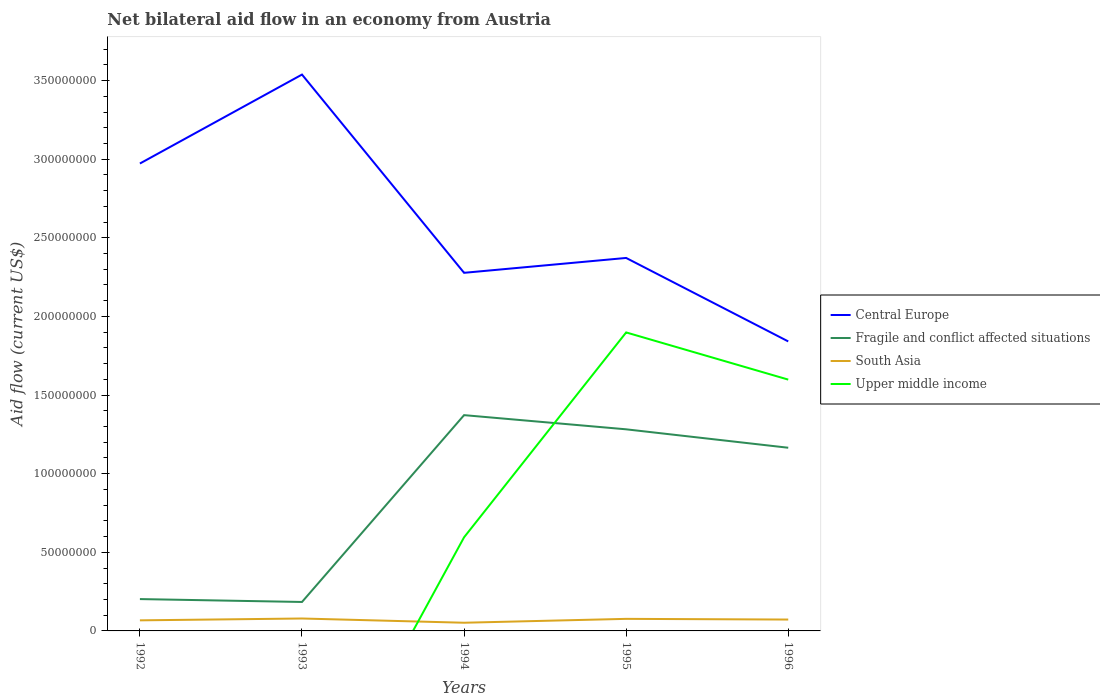How many different coloured lines are there?
Offer a terse response. 4. Is the number of lines equal to the number of legend labels?
Ensure brevity in your answer.  No. Across all years, what is the maximum net bilateral aid flow in Upper middle income?
Your response must be concise. 0. What is the total net bilateral aid flow in Upper middle income in the graph?
Offer a terse response. -1.30e+08. What is the difference between the highest and the second highest net bilateral aid flow in Central Europe?
Offer a terse response. 1.70e+08. How many lines are there?
Your response must be concise. 4. Are the values on the major ticks of Y-axis written in scientific E-notation?
Give a very brief answer. No. Does the graph contain grids?
Offer a very short reply. No. Where does the legend appear in the graph?
Your answer should be compact. Center right. How many legend labels are there?
Make the answer very short. 4. How are the legend labels stacked?
Provide a short and direct response. Vertical. What is the title of the graph?
Offer a terse response. Net bilateral aid flow in an economy from Austria. What is the Aid flow (current US$) in Central Europe in 1992?
Make the answer very short. 2.97e+08. What is the Aid flow (current US$) of Fragile and conflict affected situations in 1992?
Provide a short and direct response. 2.02e+07. What is the Aid flow (current US$) in South Asia in 1992?
Your answer should be very brief. 6.73e+06. What is the Aid flow (current US$) in Central Europe in 1993?
Your answer should be very brief. 3.54e+08. What is the Aid flow (current US$) in Fragile and conflict affected situations in 1993?
Offer a very short reply. 1.84e+07. What is the Aid flow (current US$) in South Asia in 1993?
Offer a very short reply. 7.90e+06. What is the Aid flow (current US$) of Central Europe in 1994?
Give a very brief answer. 2.28e+08. What is the Aid flow (current US$) in Fragile and conflict affected situations in 1994?
Keep it short and to the point. 1.37e+08. What is the Aid flow (current US$) of South Asia in 1994?
Your answer should be compact. 5.21e+06. What is the Aid flow (current US$) of Upper middle income in 1994?
Provide a succinct answer. 5.96e+07. What is the Aid flow (current US$) in Central Europe in 1995?
Your response must be concise. 2.37e+08. What is the Aid flow (current US$) of Fragile and conflict affected situations in 1995?
Give a very brief answer. 1.28e+08. What is the Aid flow (current US$) of South Asia in 1995?
Keep it short and to the point. 7.67e+06. What is the Aid flow (current US$) of Upper middle income in 1995?
Your answer should be compact. 1.90e+08. What is the Aid flow (current US$) in Central Europe in 1996?
Ensure brevity in your answer.  1.84e+08. What is the Aid flow (current US$) of Fragile and conflict affected situations in 1996?
Make the answer very short. 1.16e+08. What is the Aid flow (current US$) in South Asia in 1996?
Make the answer very short. 7.23e+06. What is the Aid flow (current US$) in Upper middle income in 1996?
Keep it short and to the point. 1.60e+08. Across all years, what is the maximum Aid flow (current US$) of Central Europe?
Your response must be concise. 3.54e+08. Across all years, what is the maximum Aid flow (current US$) of Fragile and conflict affected situations?
Provide a succinct answer. 1.37e+08. Across all years, what is the maximum Aid flow (current US$) in South Asia?
Your response must be concise. 7.90e+06. Across all years, what is the maximum Aid flow (current US$) in Upper middle income?
Ensure brevity in your answer.  1.90e+08. Across all years, what is the minimum Aid flow (current US$) of Central Europe?
Make the answer very short. 1.84e+08. Across all years, what is the minimum Aid flow (current US$) of Fragile and conflict affected situations?
Offer a very short reply. 1.84e+07. Across all years, what is the minimum Aid flow (current US$) of South Asia?
Provide a succinct answer. 5.21e+06. Across all years, what is the minimum Aid flow (current US$) of Upper middle income?
Make the answer very short. 0. What is the total Aid flow (current US$) of Central Europe in the graph?
Your response must be concise. 1.30e+09. What is the total Aid flow (current US$) of Fragile and conflict affected situations in the graph?
Your answer should be compact. 4.21e+08. What is the total Aid flow (current US$) of South Asia in the graph?
Offer a very short reply. 3.47e+07. What is the total Aid flow (current US$) of Upper middle income in the graph?
Make the answer very short. 4.09e+08. What is the difference between the Aid flow (current US$) in Central Europe in 1992 and that in 1993?
Ensure brevity in your answer.  -5.66e+07. What is the difference between the Aid flow (current US$) in Fragile and conflict affected situations in 1992 and that in 1993?
Your response must be concise. 1.84e+06. What is the difference between the Aid flow (current US$) in South Asia in 1992 and that in 1993?
Your answer should be compact. -1.17e+06. What is the difference between the Aid flow (current US$) in Central Europe in 1992 and that in 1994?
Your answer should be very brief. 6.95e+07. What is the difference between the Aid flow (current US$) in Fragile and conflict affected situations in 1992 and that in 1994?
Make the answer very short. -1.17e+08. What is the difference between the Aid flow (current US$) in South Asia in 1992 and that in 1994?
Offer a terse response. 1.52e+06. What is the difference between the Aid flow (current US$) of Central Europe in 1992 and that in 1995?
Offer a very short reply. 6.00e+07. What is the difference between the Aid flow (current US$) of Fragile and conflict affected situations in 1992 and that in 1995?
Your answer should be very brief. -1.08e+08. What is the difference between the Aid flow (current US$) in South Asia in 1992 and that in 1995?
Provide a succinct answer. -9.40e+05. What is the difference between the Aid flow (current US$) of Central Europe in 1992 and that in 1996?
Offer a terse response. 1.13e+08. What is the difference between the Aid flow (current US$) of Fragile and conflict affected situations in 1992 and that in 1996?
Keep it short and to the point. -9.62e+07. What is the difference between the Aid flow (current US$) in South Asia in 1992 and that in 1996?
Make the answer very short. -5.00e+05. What is the difference between the Aid flow (current US$) of Central Europe in 1993 and that in 1994?
Your answer should be very brief. 1.26e+08. What is the difference between the Aid flow (current US$) of Fragile and conflict affected situations in 1993 and that in 1994?
Provide a short and direct response. -1.19e+08. What is the difference between the Aid flow (current US$) of South Asia in 1993 and that in 1994?
Provide a short and direct response. 2.69e+06. What is the difference between the Aid flow (current US$) of Central Europe in 1993 and that in 1995?
Provide a short and direct response. 1.17e+08. What is the difference between the Aid flow (current US$) of Fragile and conflict affected situations in 1993 and that in 1995?
Your answer should be very brief. -1.10e+08. What is the difference between the Aid flow (current US$) of South Asia in 1993 and that in 1995?
Your answer should be very brief. 2.30e+05. What is the difference between the Aid flow (current US$) in Central Europe in 1993 and that in 1996?
Make the answer very short. 1.70e+08. What is the difference between the Aid flow (current US$) in Fragile and conflict affected situations in 1993 and that in 1996?
Provide a short and direct response. -9.81e+07. What is the difference between the Aid flow (current US$) in South Asia in 1993 and that in 1996?
Make the answer very short. 6.70e+05. What is the difference between the Aid flow (current US$) of Central Europe in 1994 and that in 1995?
Your response must be concise. -9.45e+06. What is the difference between the Aid flow (current US$) in Fragile and conflict affected situations in 1994 and that in 1995?
Give a very brief answer. 9.02e+06. What is the difference between the Aid flow (current US$) in South Asia in 1994 and that in 1995?
Offer a terse response. -2.46e+06. What is the difference between the Aid flow (current US$) in Upper middle income in 1994 and that in 1995?
Your response must be concise. -1.30e+08. What is the difference between the Aid flow (current US$) in Central Europe in 1994 and that in 1996?
Give a very brief answer. 4.36e+07. What is the difference between the Aid flow (current US$) in Fragile and conflict affected situations in 1994 and that in 1996?
Your answer should be compact. 2.07e+07. What is the difference between the Aid flow (current US$) of South Asia in 1994 and that in 1996?
Provide a succinct answer. -2.02e+06. What is the difference between the Aid flow (current US$) in Upper middle income in 1994 and that in 1996?
Provide a short and direct response. -1.00e+08. What is the difference between the Aid flow (current US$) in Central Europe in 1995 and that in 1996?
Give a very brief answer. 5.31e+07. What is the difference between the Aid flow (current US$) in Fragile and conflict affected situations in 1995 and that in 1996?
Provide a short and direct response. 1.17e+07. What is the difference between the Aid flow (current US$) in South Asia in 1995 and that in 1996?
Make the answer very short. 4.40e+05. What is the difference between the Aid flow (current US$) of Upper middle income in 1995 and that in 1996?
Your answer should be very brief. 3.00e+07. What is the difference between the Aid flow (current US$) in Central Europe in 1992 and the Aid flow (current US$) in Fragile and conflict affected situations in 1993?
Keep it short and to the point. 2.79e+08. What is the difference between the Aid flow (current US$) in Central Europe in 1992 and the Aid flow (current US$) in South Asia in 1993?
Give a very brief answer. 2.89e+08. What is the difference between the Aid flow (current US$) of Fragile and conflict affected situations in 1992 and the Aid flow (current US$) of South Asia in 1993?
Make the answer very short. 1.24e+07. What is the difference between the Aid flow (current US$) in Central Europe in 1992 and the Aid flow (current US$) in Fragile and conflict affected situations in 1994?
Provide a short and direct response. 1.60e+08. What is the difference between the Aid flow (current US$) in Central Europe in 1992 and the Aid flow (current US$) in South Asia in 1994?
Offer a terse response. 2.92e+08. What is the difference between the Aid flow (current US$) in Central Europe in 1992 and the Aid flow (current US$) in Upper middle income in 1994?
Your response must be concise. 2.38e+08. What is the difference between the Aid flow (current US$) of Fragile and conflict affected situations in 1992 and the Aid flow (current US$) of South Asia in 1994?
Provide a succinct answer. 1.50e+07. What is the difference between the Aid flow (current US$) in Fragile and conflict affected situations in 1992 and the Aid flow (current US$) in Upper middle income in 1994?
Provide a short and direct response. -3.93e+07. What is the difference between the Aid flow (current US$) of South Asia in 1992 and the Aid flow (current US$) of Upper middle income in 1994?
Keep it short and to the point. -5.28e+07. What is the difference between the Aid flow (current US$) of Central Europe in 1992 and the Aid flow (current US$) of Fragile and conflict affected situations in 1995?
Your answer should be compact. 1.69e+08. What is the difference between the Aid flow (current US$) in Central Europe in 1992 and the Aid flow (current US$) in South Asia in 1995?
Keep it short and to the point. 2.90e+08. What is the difference between the Aid flow (current US$) of Central Europe in 1992 and the Aid flow (current US$) of Upper middle income in 1995?
Ensure brevity in your answer.  1.07e+08. What is the difference between the Aid flow (current US$) in Fragile and conflict affected situations in 1992 and the Aid flow (current US$) in South Asia in 1995?
Your response must be concise. 1.26e+07. What is the difference between the Aid flow (current US$) of Fragile and conflict affected situations in 1992 and the Aid flow (current US$) of Upper middle income in 1995?
Keep it short and to the point. -1.70e+08. What is the difference between the Aid flow (current US$) in South Asia in 1992 and the Aid flow (current US$) in Upper middle income in 1995?
Make the answer very short. -1.83e+08. What is the difference between the Aid flow (current US$) in Central Europe in 1992 and the Aid flow (current US$) in Fragile and conflict affected situations in 1996?
Your answer should be very brief. 1.81e+08. What is the difference between the Aid flow (current US$) of Central Europe in 1992 and the Aid flow (current US$) of South Asia in 1996?
Your answer should be compact. 2.90e+08. What is the difference between the Aid flow (current US$) of Central Europe in 1992 and the Aid flow (current US$) of Upper middle income in 1996?
Make the answer very short. 1.37e+08. What is the difference between the Aid flow (current US$) in Fragile and conflict affected situations in 1992 and the Aid flow (current US$) in South Asia in 1996?
Keep it short and to the point. 1.30e+07. What is the difference between the Aid flow (current US$) in Fragile and conflict affected situations in 1992 and the Aid flow (current US$) in Upper middle income in 1996?
Your answer should be compact. -1.40e+08. What is the difference between the Aid flow (current US$) in South Asia in 1992 and the Aid flow (current US$) in Upper middle income in 1996?
Ensure brevity in your answer.  -1.53e+08. What is the difference between the Aid flow (current US$) in Central Europe in 1993 and the Aid flow (current US$) in Fragile and conflict affected situations in 1994?
Make the answer very short. 2.17e+08. What is the difference between the Aid flow (current US$) of Central Europe in 1993 and the Aid flow (current US$) of South Asia in 1994?
Provide a short and direct response. 3.49e+08. What is the difference between the Aid flow (current US$) in Central Europe in 1993 and the Aid flow (current US$) in Upper middle income in 1994?
Your answer should be very brief. 2.94e+08. What is the difference between the Aid flow (current US$) in Fragile and conflict affected situations in 1993 and the Aid flow (current US$) in South Asia in 1994?
Keep it short and to the point. 1.32e+07. What is the difference between the Aid flow (current US$) of Fragile and conflict affected situations in 1993 and the Aid flow (current US$) of Upper middle income in 1994?
Ensure brevity in your answer.  -4.11e+07. What is the difference between the Aid flow (current US$) in South Asia in 1993 and the Aid flow (current US$) in Upper middle income in 1994?
Give a very brief answer. -5.16e+07. What is the difference between the Aid flow (current US$) of Central Europe in 1993 and the Aid flow (current US$) of Fragile and conflict affected situations in 1995?
Provide a short and direct response. 2.26e+08. What is the difference between the Aid flow (current US$) in Central Europe in 1993 and the Aid flow (current US$) in South Asia in 1995?
Give a very brief answer. 3.46e+08. What is the difference between the Aid flow (current US$) in Central Europe in 1993 and the Aid flow (current US$) in Upper middle income in 1995?
Make the answer very short. 1.64e+08. What is the difference between the Aid flow (current US$) in Fragile and conflict affected situations in 1993 and the Aid flow (current US$) in South Asia in 1995?
Keep it short and to the point. 1.07e+07. What is the difference between the Aid flow (current US$) in Fragile and conflict affected situations in 1993 and the Aid flow (current US$) in Upper middle income in 1995?
Your answer should be very brief. -1.71e+08. What is the difference between the Aid flow (current US$) in South Asia in 1993 and the Aid flow (current US$) in Upper middle income in 1995?
Give a very brief answer. -1.82e+08. What is the difference between the Aid flow (current US$) of Central Europe in 1993 and the Aid flow (current US$) of Fragile and conflict affected situations in 1996?
Make the answer very short. 2.37e+08. What is the difference between the Aid flow (current US$) of Central Europe in 1993 and the Aid flow (current US$) of South Asia in 1996?
Give a very brief answer. 3.47e+08. What is the difference between the Aid flow (current US$) in Central Europe in 1993 and the Aid flow (current US$) in Upper middle income in 1996?
Provide a succinct answer. 1.94e+08. What is the difference between the Aid flow (current US$) in Fragile and conflict affected situations in 1993 and the Aid flow (current US$) in South Asia in 1996?
Your response must be concise. 1.12e+07. What is the difference between the Aid flow (current US$) of Fragile and conflict affected situations in 1993 and the Aid flow (current US$) of Upper middle income in 1996?
Offer a very short reply. -1.41e+08. What is the difference between the Aid flow (current US$) in South Asia in 1993 and the Aid flow (current US$) in Upper middle income in 1996?
Your response must be concise. -1.52e+08. What is the difference between the Aid flow (current US$) in Central Europe in 1994 and the Aid flow (current US$) in Fragile and conflict affected situations in 1995?
Your answer should be very brief. 9.95e+07. What is the difference between the Aid flow (current US$) of Central Europe in 1994 and the Aid flow (current US$) of South Asia in 1995?
Your answer should be very brief. 2.20e+08. What is the difference between the Aid flow (current US$) in Central Europe in 1994 and the Aid flow (current US$) in Upper middle income in 1995?
Your answer should be compact. 3.79e+07. What is the difference between the Aid flow (current US$) in Fragile and conflict affected situations in 1994 and the Aid flow (current US$) in South Asia in 1995?
Offer a very short reply. 1.30e+08. What is the difference between the Aid flow (current US$) of Fragile and conflict affected situations in 1994 and the Aid flow (current US$) of Upper middle income in 1995?
Your answer should be compact. -5.26e+07. What is the difference between the Aid flow (current US$) in South Asia in 1994 and the Aid flow (current US$) in Upper middle income in 1995?
Your answer should be compact. -1.85e+08. What is the difference between the Aid flow (current US$) in Central Europe in 1994 and the Aid flow (current US$) in Fragile and conflict affected situations in 1996?
Keep it short and to the point. 1.11e+08. What is the difference between the Aid flow (current US$) of Central Europe in 1994 and the Aid flow (current US$) of South Asia in 1996?
Make the answer very short. 2.21e+08. What is the difference between the Aid flow (current US$) in Central Europe in 1994 and the Aid flow (current US$) in Upper middle income in 1996?
Give a very brief answer. 6.79e+07. What is the difference between the Aid flow (current US$) of Fragile and conflict affected situations in 1994 and the Aid flow (current US$) of South Asia in 1996?
Provide a succinct answer. 1.30e+08. What is the difference between the Aid flow (current US$) of Fragile and conflict affected situations in 1994 and the Aid flow (current US$) of Upper middle income in 1996?
Your answer should be very brief. -2.26e+07. What is the difference between the Aid flow (current US$) in South Asia in 1994 and the Aid flow (current US$) in Upper middle income in 1996?
Keep it short and to the point. -1.55e+08. What is the difference between the Aid flow (current US$) in Central Europe in 1995 and the Aid flow (current US$) in Fragile and conflict affected situations in 1996?
Your answer should be compact. 1.21e+08. What is the difference between the Aid flow (current US$) in Central Europe in 1995 and the Aid flow (current US$) in South Asia in 1996?
Ensure brevity in your answer.  2.30e+08. What is the difference between the Aid flow (current US$) in Central Europe in 1995 and the Aid flow (current US$) in Upper middle income in 1996?
Offer a terse response. 7.74e+07. What is the difference between the Aid flow (current US$) in Fragile and conflict affected situations in 1995 and the Aid flow (current US$) in South Asia in 1996?
Keep it short and to the point. 1.21e+08. What is the difference between the Aid flow (current US$) of Fragile and conflict affected situations in 1995 and the Aid flow (current US$) of Upper middle income in 1996?
Keep it short and to the point. -3.16e+07. What is the difference between the Aid flow (current US$) in South Asia in 1995 and the Aid flow (current US$) in Upper middle income in 1996?
Provide a short and direct response. -1.52e+08. What is the average Aid flow (current US$) in Central Europe per year?
Your answer should be very brief. 2.60e+08. What is the average Aid flow (current US$) of Fragile and conflict affected situations per year?
Your answer should be compact. 8.41e+07. What is the average Aid flow (current US$) of South Asia per year?
Provide a short and direct response. 6.95e+06. What is the average Aid flow (current US$) of Upper middle income per year?
Provide a short and direct response. 8.18e+07. In the year 1992, what is the difference between the Aid flow (current US$) in Central Europe and Aid flow (current US$) in Fragile and conflict affected situations?
Provide a succinct answer. 2.77e+08. In the year 1992, what is the difference between the Aid flow (current US$) in Central Europe and Aid flow (current US$) in South Asia?
Offer a terse response. 2.91e+08. In the year 1992, what is the difference between the Aid flow (current US$) of Fragile and conflict affected situations and Aid flow (current US$) of South Asia?
Keep it short and to the point. 1.35e+07. In the year 1993, what is the difference between the Aid flow (current US$) in Central Europe and Aid flow (current US$) in Fragile and conflict affected situations?
Give a very brief answer. 3.35e+08. In the year 1993, what is the difference between the Aid flow (current US$) of Central Europe and Aid flow (current US$) of South Asia?
Provide a short and direct response. 3.46e+08. In the year 1993, what is the difference between the Aid flow (current US$) in Fragile and conflict affected situations and Aid flow (current US$) in South Asia?
Your response must be concise. 1.05e+07. In the year 1994, what is the difference between the Aid flow (current US$) of Central Europe and Aid flow (current US$) of Fragile and conflict affected situations?
Your response must be concise. 9.05e+07. In the year 1994, what is the difference between the Aid flow (current US$) of Central Europe and Aid flow (current US$) of South Asia?
Offer a very short reply. 2.23e+08. In the year 1994, what is the difference between the Aid flow (current US$) of Central Europe and Aid flow (current US$) of Upper middle income?
Give a very brief answer. 1.68e+08. In the year 1994, what is the difference between the Aid flow (current US$) of Fragile and conflict affected situations and Aid flow (current US$) of South Asia?
Your response must be concise. 1.32e+08. In the year 1994, what is the difference between the Aid flow (current US$) of Fragile and conflict affected situations and Aid flow (current US$) of Upper middle income?
Your answer should be very brief. 7.77e+07. In the year 1994, what is the difference between the Aid flow (current US$) in South Asia and Aid flow (current US$) in Upper middle income?
Offer a very short reply. -5.43e+07. In the year 1995, what is the difference between the Aid flow (current US$) of Central Europe and Aid flow (current US$) of Fragile and conflict affected situations?
Your response must be concise. 1.09e+08. In the year 1995, what is the difference between the Aid flow (current US$) of Central Europe and Aid flow (current US$) of South Asia?
Your answer should be very brief. 2.30e+08. In the year 1995, what is the difference between the Aid flow (current US$) of Central Europe and Aid flow (current US$) of Upper middle income?
Ensure brevity in your answer.  4.74e+07. In the year 1995, what is the difference between the Aid flow (current US$) in Fragile and conflict affected situations and Aid flow (current US$) in South Asia?
Provide a succinct answer. 1.21e+08. In the year 1995, what is the difference between the Aid flow (current US$) of Fragile and conflict affected situations and Aid flow (current US$) of Upper middle income?
Offer a terse response. -6.16e+07. In the year 1995, what is the difference between the Aid flow (current US$) in South Asia and Aid flow (current US$) in Upper middle income?
Offer a terse response. -1.82e+08. In the year 1996, what is the difference between the Aid flow (current US$) in Central Europe and Aid flow (current US$) in Fragile and conflict affected situations?
Provide a succinct answer. 6.76e+07. In the year 1996, what is the difference between the Aid flow (current US$) of Central Europe and Aid flow (current US$) of South Asia?
Your answer should be compact. 1.77e+08. In the year 1996, what is the difference between the Aid flow (current US$) of Central Europe and Aid flow (current US$) of Upper middle income?
Provide a succinct answer. 2.43e+07. In the year 1996, what is the difference between the Aid flow (current US$) in Fragile and conflict affected situations and Aid flow (current US$) in South Asia?
Your response must be concise. 1.09e+08. In the year 1996, what is the difference between the Aid flow (current US$) in Fragile and conflict affected situations and Aid flow (current US$) in Upper middle income?
Ensure brevity in your answer.  -4.33e+07. In the year 1996, what is the difference between the Aid flow (current US$) of South Asia and Aid flow (current US$) of Upper middle income?
Your answer should be compact. -1.53e+08. What is the ratio of the Aid flow (current US$) of Central Europe in 1992 to that in 1993?
Offer a very short reply. 0.84. What is the ratio of the Aid flow (current US$) of Fragile and conflict affected situations in 1992 to that in 1993?
Make the answer very short. 1.1. What is the ratio of the Aid flow (current US$) of South Asia in 1992 to that in 1993?
Offer a terse response. 0.85. What is the ratio of the Aid flow (current US$) in Central Europe in 1992 to that in 1994?
Give a very brief answer. 1.31. What is the ratio of the Aid flow (current US$) of Fragile and conflict affected situations in 1992 to that in 1994?
Offer a very short reply. 0.15. What is the ratio of the Aid flow (current US$) of South Asia in 1992 to that in 1994?
Offer a very short reply. 1.29. What is the ratio of the Aid flow (current US$) in Central Europe in 1992 to that in 1995?
Ensure brevity in your answer.  1.25. What is the ratio of the Aid flow (current US$) in Fragile and conflict affected situations in 1992 to that in 1995?
Provide a short and direct response. 0.16. What is the ratio of the Aid flow (current US$) in South Asia in 1992 to that in 1995?
Provide a short and direct response. 0.88. What is the ratio of the Aid flow (current US$) in Central Europe in 1992 to that in 1996?
Offer a terse response. 1.61. What is the ratio of the Aid flow (current US$) in Fragile and conflict affected situations in 1992 to that in 1996?
Provide a short and direct response. 0.17. What is the ratio of the Aid flow (current US$) of South Asia in 1992 to that in 1996?
Your response must be concise. 0.93. What is the ratio of the Aid flow (current US$) in Central Europe in 1993 to that in 1994?
Your response must be concise. 1.55. What is the ratio of the Aid flow (current US$) of Fragile and conflict affected situations in 1993 to that in 1994?
Offer a very short reply. 0.13. What is the ratio of the Aid flow (current US$) in South Asia in 1993 to that in 1994?
Your answer should be very brief. 1.52. What is the ratio of the Aid flow (current US$) of Central Europe in 1993 to that in 1995?
Your answer should be compact. 1.49. What is the ratio of the Aid flow (current US$) in Fragile and conflict affected situations in 1993 to that in 1995?
Your response must be concise. 0.14. What is the ratio of the Aid flow (current US$) of South Asia in 1993 to that in 1995?
Keep it short and to the point. 1.03. What is the ratio of the Aid flow (current US$) in Central Europe in 1993 to that in 1996?
Give a very brief answer. 1.92. What is the ratio of the Aid flow (current US$) in Fragile and conflict affected situations in 1993 to that in 1996?
Provide a short and direct response. 0.16. What is the ratio of the Aid flow (current US$) of South Asia in 1993 to that in 1996?
Make the answer very short. 1.09. What is the ratio of the Aid flow (current US$) in Central Europe in 1994 to that in 1995?
Your response must be concise. 0.96. What is the ratio of the Aid flow (current US$) in Fragile and conflict affected situations in 1994 to that in 1995?
Make the answer very short. 1.07. What is the ratio of the Aid flow (current US$) of South Asia in 1994 to that in 1995?
Give a very brief answer. 0.68. What is the ratio of the Aid flow (current US$) in Upper middle income in 1994 to that in 1995?
Give a very brief answer. 0.31. What is the ratio of the Aid flow (current US$) of Central Europe in 1994 to that in 1996?
Provide a short and direct response. 1.24. What is the ratio of the Aid flow (current US$) in Fragile and conflict affected situations in 1994 to that in 1996?
Your answer should be compact. 1.18. What is the ratio of the Aid flow (current US$) in South Asia in 1994 to that in 1996?
Provide a succinct answer. 0.72. What is the ratio of the Aid flow (current US$) of Upper middle income in 1994 to that in 1996?
Offer a very short reply. 0.37. What is the ratio of the Aid flow (current US$) of Central Europe in 1995 to that in 1996?
Your response must be concise. 1.29. What is the ratio of the Aid flow (current US$) in Fragile and conflict affected situations in 1995 to that in 1996?
Offer a terse response. 1.1. What is the ratio of the Aid flow (current US$) of South Asia in 1995 to that in 1996?
Give a very brief answer. 1.06. What is the ratio of the Aid flow (current US$) of Upper middle income in 1995 to that in 1996?
Provide a succinct answer. 1.19. What is the difference between the highest and the second highest Aid flow (current US$) of Central Europe?
Provide a short and direct response. 5.66e+07. What is the difference between the highest and the second highest Aid flow (current US$) in Fragile and conflict affected situations?
Ensure brevity in your answer.  9.02e+06. What is the difference between the highest and the second highest Aid flow (current US$) of South Asia?
Your answer should be compact. 2.30e+05. What is the difference between the highest and the second highest Aid flow (current US$) in Upper middle income?
Your response must be concise. 3.00e+07. What is the difference between the highest and the lowest Aid flow (current US$) in Central Europe?
Your response must be concise. 1.70e+08. What is the difference between the highest and the lowest Aid flow (current US$) in Fragile and conflict affected situations?
Keep it short and to the point. 1.19e+08. What is the difference between the highest and the lowest Aid flow (current US$) of South Asia?
Keep it short and to the point. 2.69e+06. What is the difference between the highest and the lowest Aid flow (current US$) of Upper middle income?
Keep it short and to the point. 1.90e+08. 